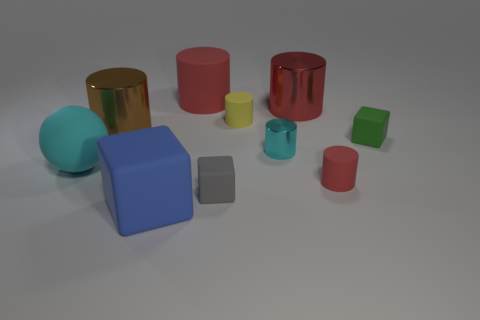What is the color of the large thing that is the same shape as the small green object?
Offer a terse response. Blue. What is the size of the brown metallic object?
Offer a very short reply. Large. What number of cylinders are large things or big red metallic objects?
Offer a very short reply. 3. What is the size of the yellow matte thing that is the same shape as the brown thing?
Give a very brief answer. Small. What number of things are there?
Provide a succinct answer. 10. Does the tiny gray rubber thing have the same shape as the big blue matte object that is on the left side of the green matte object?
Offer a very short reply. Yes. What is the size of the red rubber cylinder behind the red shiny cylinder?
Your response must be concise. Large. What is the material of the brown cylinder?
Your answer should be very brief. Metal. There is a red matte thing behind the tiny yellow cylinder; is its shape the same as the small gray rubber thing?
Keep it short and to the point. No. There is a matte object that is the same color as the small shiny object; what size is it?
Ensure brevity in your answer.  Large. 